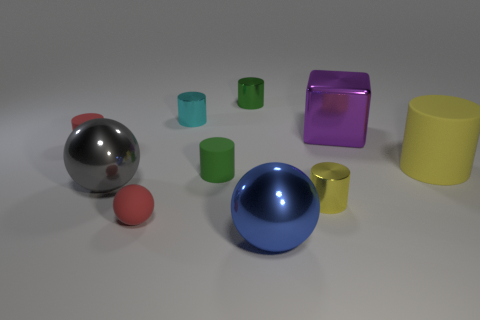Can you explain the apparent lighting conditions of the scene depicted in this image? The scene is illuminated by what appears to be a uniform light source, casting soft shadows directly beneath the objects. This lighting suggests an indoor environment, possibly a studio setup, designed to reduce harsh shadows and allow the colors and textures of the objects to be observed clearly. 